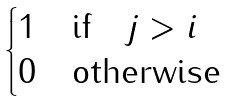Convert formula to latex. <formula><loc_0><loc_0><loc_500><loc_500>\begin{cases} 1 \quad \text {if} \quad j > i \\ 0 \quad \text {otherwise} \end{cases}</formula> 